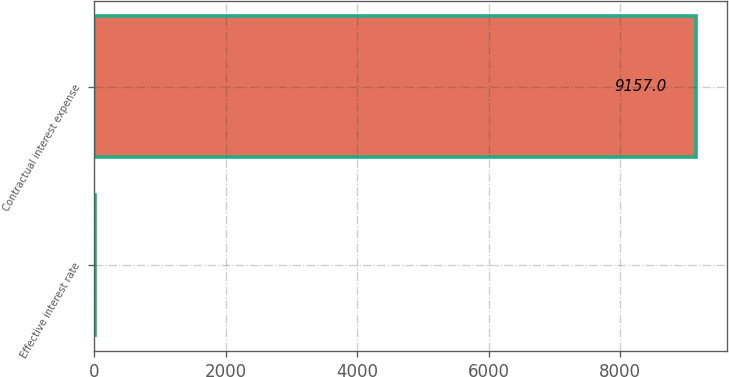Convert chart to OTSL. <chart><loc_0><loc_0><loc_500><loc_500><bar_chart><fcel>Effective interest rate<fcel>Contractual interest expense<nl><fcel>8.1<fcel>9157<nl></chart> 